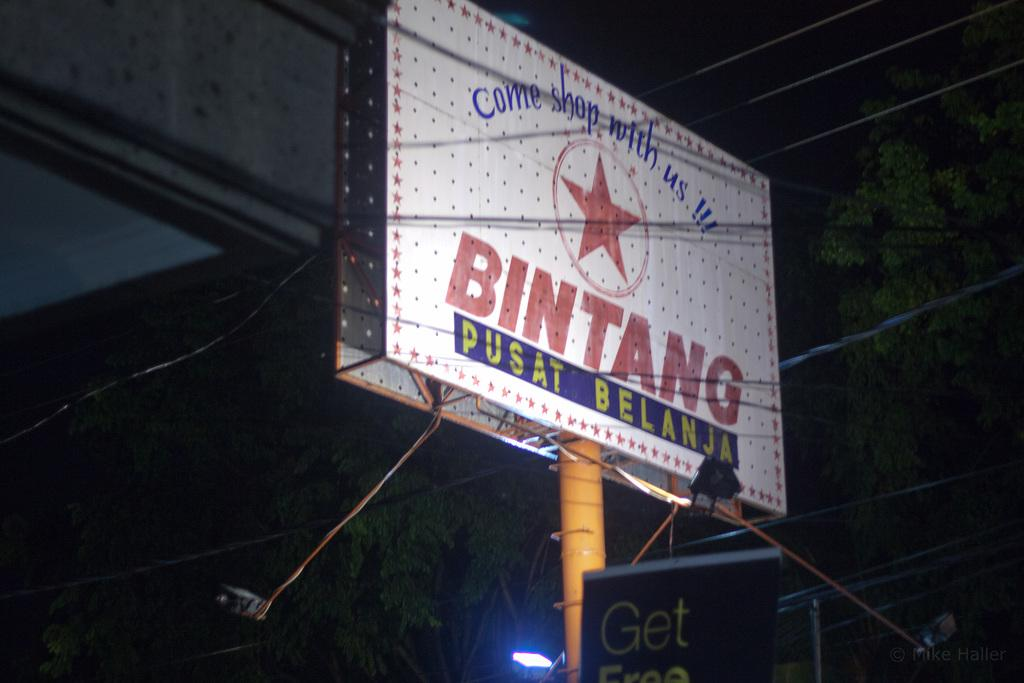Provide a one-sentence caption for the provided image. An enthusiastic billboard invites consumers to "come shop" with them. 